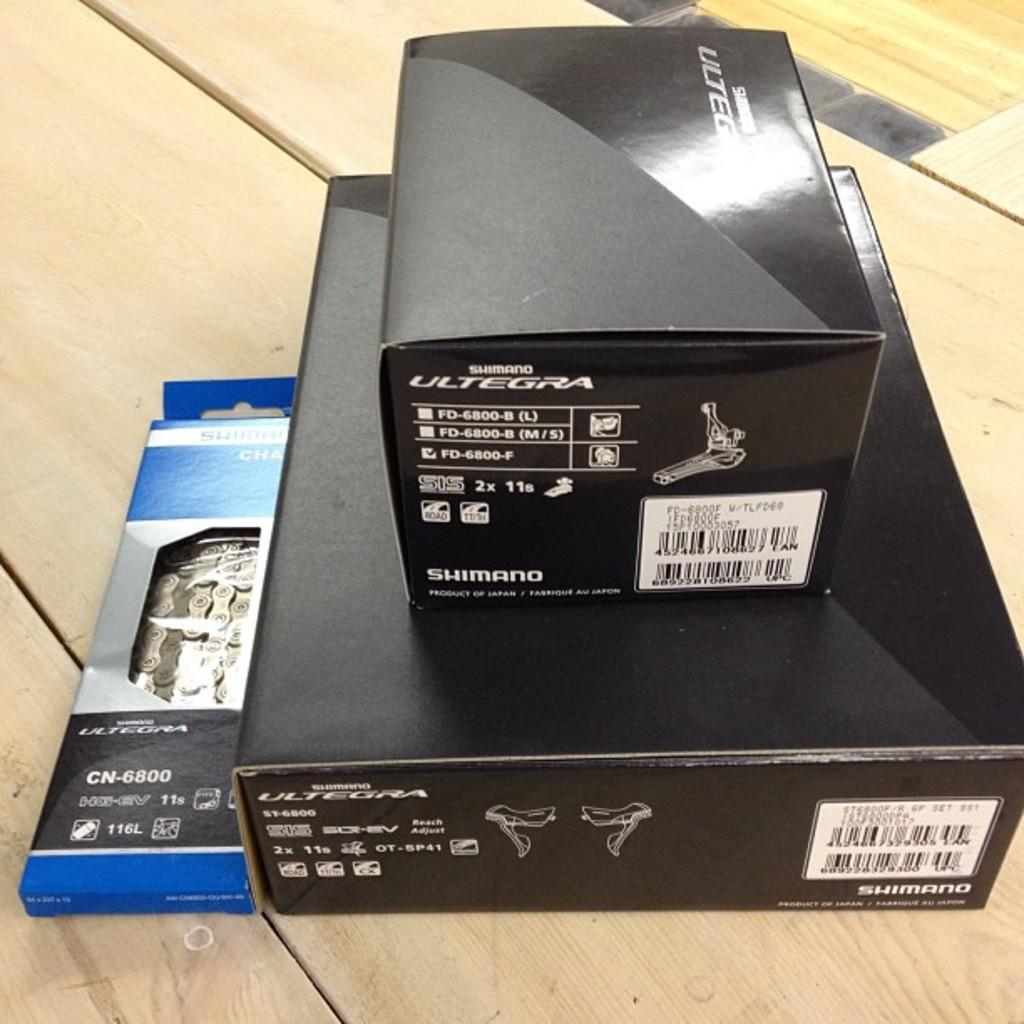<image>
Describe the image concisely. Small black box for Ultegra on top of a bigger black box. 